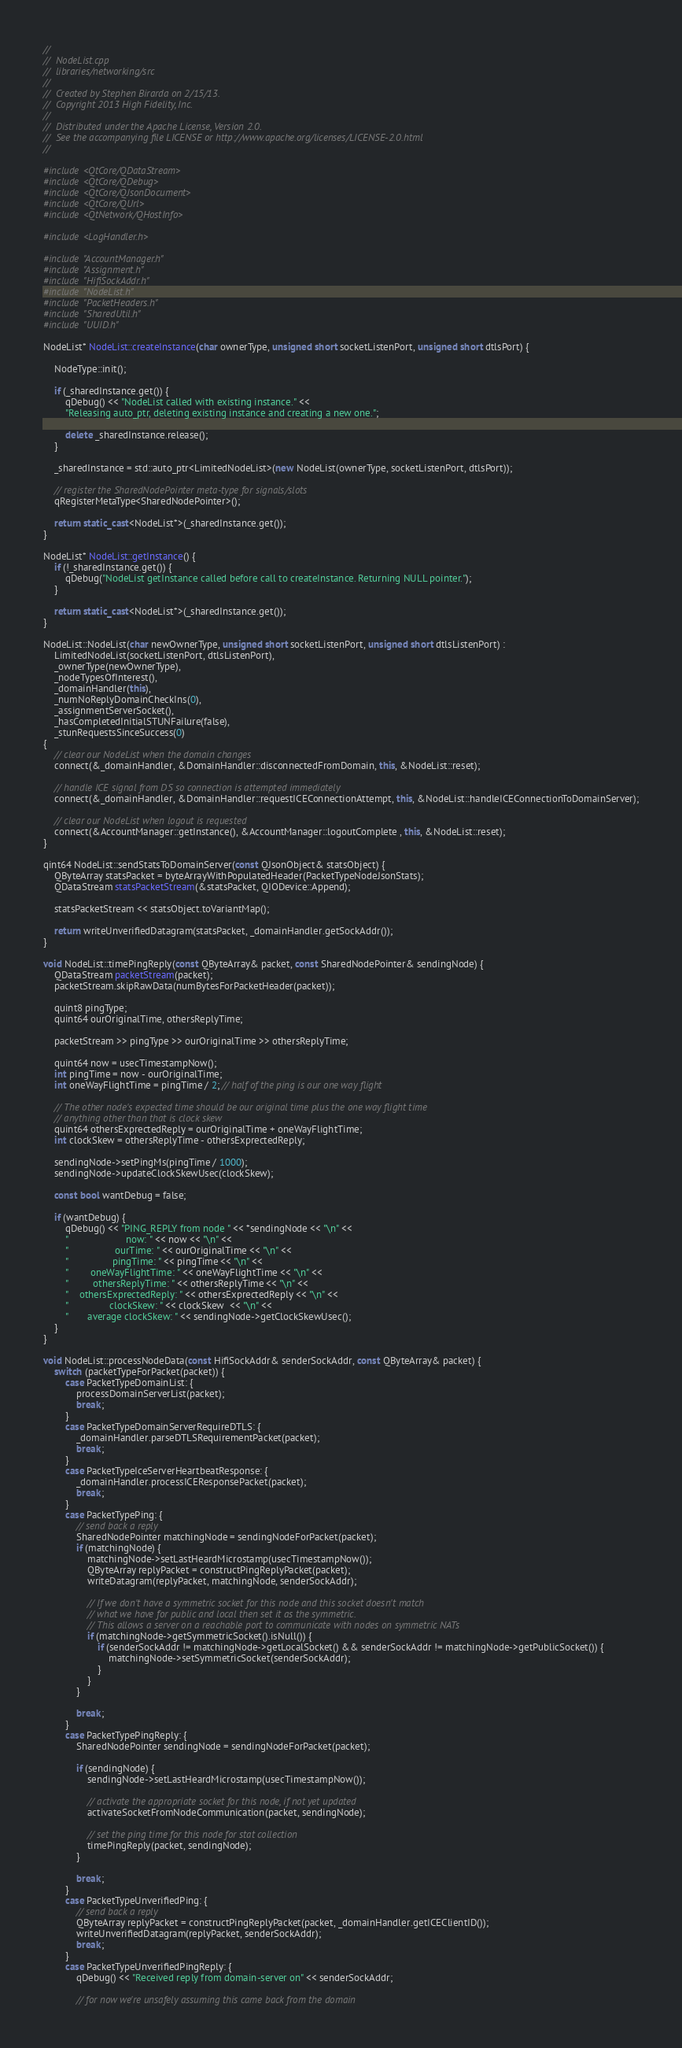Convert code to text. <code><loc_0><loc_0><loc_500><loc_500><_C++_>//
//  NodeList.cpp
//  libraries/networking/src
//
//  Created by Stephen Birarda on 2/15/13.
//  Copyright 2013 High Fidelity, Inc.
//
//  Distributed under the Apache License, Version 2.0.
//  See the accompanying file LICENSE or http://www.apache.org/licenses/LICENSE-2.0.html
//

#include <QtCore/QDataStream>
#include <QtCore/QDebug>
#include <QtCore/QJsonDocument>
#include <QtCore/QUrl>
#include <QtNetwork/QHostInfo>

#include <LogHandler.h>

#include "AccountManager.h"
#include "Assignment.h"
#include "HifiSockAddr.h"
#include "NodeList.h"
#include "PacketHeaders.h"
#include "SharedUtil.h"
#include "UUID.h"

NodeList* NodeList::createInstance(char ownerType, unsigned short socketListenPort, unsigned short dtlsPort) {
    
    NodeType::init();
    
    if (_sharedInstance.get()) {
        qDebug() << "NodeList called with existing instance." <<
        "Releasing auto_ptr, deleting existing instance and creating a new one.";
        
        delete _sharedInstance.release();
    }
    
    _sharedInstance = std::auto_ptr<LimitedNodeList>(new NodeList(ownerType, socketListenPort, dtlsPort));
    
    // register the SharedNodePointer meta-type for signals/slots
    qRegisterMetaType<SharedNodePointer>();
    
    return static_cast<NodeList*>(_sharedInstance.get());
}

NodeList* NodeList::getInstance() {
    if (!_sharedInstance.get()) {
        qDebug("NodeList getInstance called before call to createInstance. Returning NULL pointer.");
    }

    return static_cast<NodeList*>(_sharedInstance.get());
}

NodeList::NodeList(char newOwnerType, unsigned short socketListenPort, unsigned short dtlsListenPort) :
    LimitedNodeList(socketListenPort, dtlsListenPort),
    _ownerType(newOwnerType),
    _nodeTypesOfInterest(),
    _domainHandler(this),
    _numNoReplyDomainCheckIns(0),
    _assignmentServerSocket(),
    _hasCompletedInitialSTUNFailure(false),
    _stunRequestsSinceSuccess(0)
{
    // clear our NodeList when the domain changes
    connect(&_domainHandler, &DomainHandler::disconnectedFromDomain, this, &NodeList::reset);
    
    // handle ICE signal from DS so connection is attempted immediately
    connect(&_domainHandler, &DomainHandler::requestICEConnectionAttempt, this, &NodeList::handleICEConnectionToDomainServer);
    
    // clear our NodeList when logout is requested
    connect(&AccountManager::getInstance(), &AccountManager::logoutComplete , this, &NodeList::reset);
}

qint64 NodeList::sendStatsToDomainServer(const QJsonObject& statsObject) {
    QByteArray statsPacket = byteArrayWithPopulatedHeader(PacketTypeNodeJsonStats);
    QDataStream statsPacketStream(&statsPacket, QIODevice::Append);
    
    statsPacketStream << statsObject.toVariantMap();
    
    return writeUnverifiedDatagram(statsPacket, _domainHandler.getSockAddr());
}

void NodeList::timePingReply(const QByteArray& packet, const SharedNodePointer& sendingNode) {
    QDataStream packetStream(packet);
    packetStream.skipRawData(numBytesForPacketHeader(packet));
    
    quint8 pingType;
    quint64 ourOriginalTime, othersReplyTime;
    
    packetStream >> pingType >> ourOriginalTime >> othersReplyTime;
    
    quint64 now = usecTimestampNow();
    int pingTime = now - ourOriginalTime;
    int oneWayFlightTime = pingTime / 2; // half of the ping is our one way flight
    
    // The other node's expected time should be our original time plus the one way flight time
    // anything other than that is clock skew
    quint64 othersExprectedReply = ourOriginalTime + oneWayFlightTime;
    int clockSkew = othersReplyTime - othersExprectedReply;
    
    sendingNode->setPingMs(pingTime / 1000);
    sendingNode->updateClockSkewUsec(clockSkew);

    const bool wantDebug = false;
    
    if (wantDebug) {
        qDebug() << "PING_REPLY from node " << *sendingNode << "\n" <<
        "                     now: " << now << "\n" <<
        "                 ourTime: " << ourOriginalTime << "\n" <<
        "                pingTime: " << pingTime << "\n" <<
        "        oneWayFlightTime: " << oneWayFlightTime << "\n" <<
        "         othersReplyTime: " << othersReplyTime << "\n" <<
        "    othersExprectedReply: " << othersExprectedReply << "\n" <<
        "               clockSkew: " << clockSkew  << "\n" <<
        "       average clockSkew: " << sendingNode->getClockSkewUsec();
    }
}

void NodeList::processNodeData(const HifiSockAddr& senderSockAddr, const QByteArray& packet) {
    switch (packetTypeForPacket(packet)) {
        case PacketTypeDomainList: {
            processDomainServerList(packet);
            break;
        }
        case PacketTypeDomainServerRequireDTLS: {
            _domainHandler.parseDTLSRequirementPacket(packet);
            break;
        }
        case PacketTypeIceServerHeartbeatResponse: {
            _domainHandler.processICEResponsePacket(packet);
            break;
        }
        case PacketTypePing: {
            // send back a reply
            SharedNodePointer matchingNode = sendingNodeForPacket(packet);
            if (matchingNode) {
                matchingNode->setLastHeardMicrostamp(usecTimestampNow());
                QByteArray replyPacket = constructPingReplyPacket(packet);
                writeDatagram(replyPacket, matchingNode, senderSockAddr);
                
                // If we don't have a symmetric socket for this node and this socket doesn't match
                // what we have for public and local then set it as the symmetric.
                // This allows a server on a reachable port to communicate with nodes on symmetric NATs
                if (matchingNode->getSymmetricSocket().isNull()) {
                    if (senderSockAddr != matchingNode->getLocalSocket() && senderSockAddr != matchingNode->getPublicSocket()) {
                        matchingNode->setSymmetricSocket(senderSockAddr);
                    }
                }
            }
            
            break;
        }
        case PacketTypePingReply: {
            SharedNodePointer sendingNode = sendingNodeForPacket(packet);
            
            if (sendingNode) {
                sendingNode->setLastHeardMicrostamp(usecTimestampNow());
                
                // activate the appropriate socket for this node, if not yet updated
                activateSocketFromNodeCommunication(packet, sendingNode);
                
                // set the ping time for this node for stat collection
                timePingReply(packet, sendingNode);
            }
            
            break;
        }
        case PacketTypeUnverifiedPing: {
            // send back a reply
            QByteArray replyPacket = constructPingReplyPacket(packet, _domainHandler.getICEClientID());
            writeUnverifiedDatagram(replyPacket, senderSockAddr);
            break;
        }
        case PacketTypeUnverifiedPingReply: {
            qDebug() << "Received reply from domain-server on" << senderSockAddr;
            
            // for now we're unsafely assuming this came back from the domain</code> 